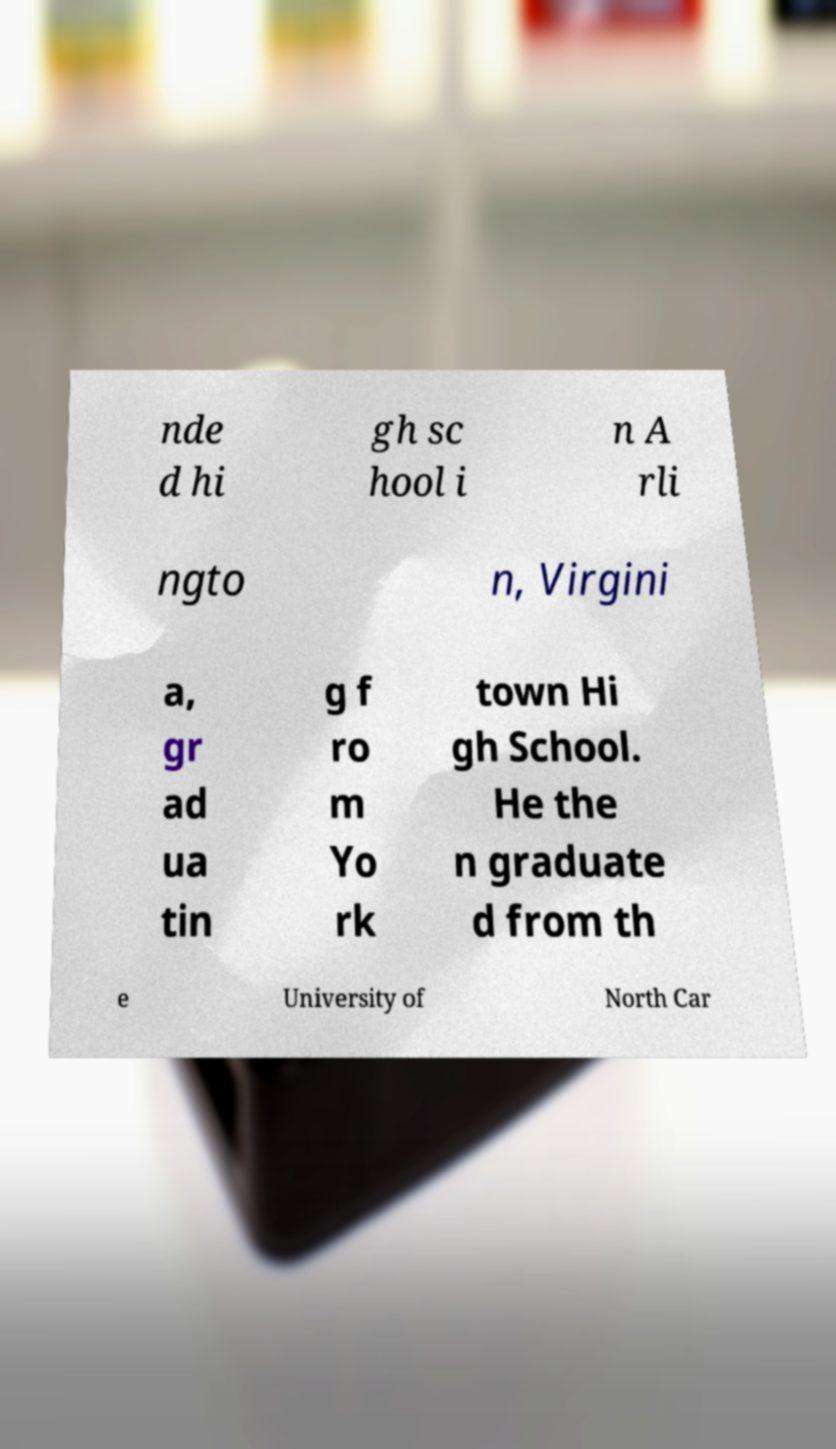Could you extract and type out the text from this image? nde d hi gh sc hool i n A rli ngto n, Virgini a, gr ad ua tin g f ro m Yo rk town Hi gh School. He the n graduate d from th e University of North Car 